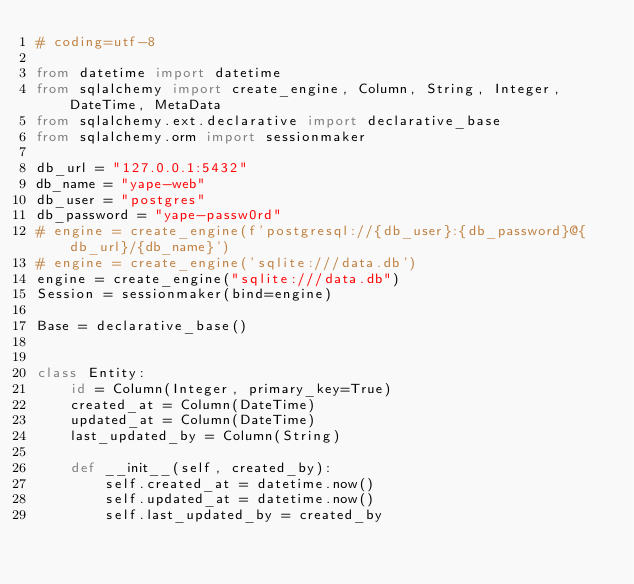Convert code to text. <code><loc_0><loc_0><loc_500><loc_500><_Python_># coding=utf-8

from datetime import datetime
from sqlalchemy import create_engine, Column, String, Integer, DateTime, MetaData
from sqlalchemy.ext.declarative import declarative_base
from sqlalchemy.orm import sessionmaker

db_url = "127.0.0.1:5432"
db_name = "yape-web"
db_user = "postgres"
db_password = "yape-passw0rd"
# engine = create_engine(f'postgresql://{db_user}:{db_password}@{db_url}/{db_name}')
# engine = create_engine('sqlite:///data.db')
engine = create_engine("sqlite:///data.db")
Session = sessionmaker(bind=engine)

Base = declarative_base()


class Entity:
    id = Column(Integer, primary_key=True)
    created_at = Column(DateTime)
    updated_at = Column(DateTime)
    last_updated_by = Column(String)

    def __init__(self, created_by):
        self.created_at = datetime.now()
        self.updated_at = datetime.now()
        self.last_updated_by = created_by
</code> 